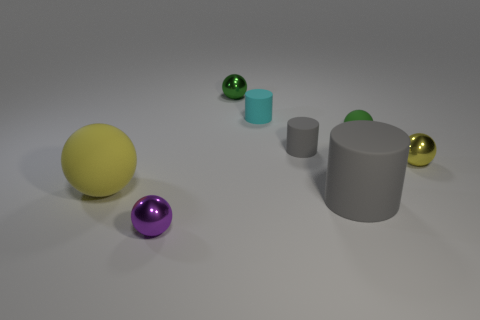Subtract all tiny yellow shiny balls. How many balls are left? 4 Subtract all gray cubes. How many yellow balls are left? 2 Subtract 2 cylinders. How many cylinders are left? 1 Subtract all cyan cylinders. How many cylinders are left? 2 Add 2 tiny yellow spheres. How many objects exist? 10 Subtract all spheres. How many objects are left? 3 Add 5 matte balls. How many matte balls are left? 7 Add 5 purple metallic balls. How many purple metallic balls exist? 6 Subtract 0 blue spheres. How many objects are left? 8 Subtract all yellow cylinders. Subtract all brown blocks. How many cylinders are left? 3 